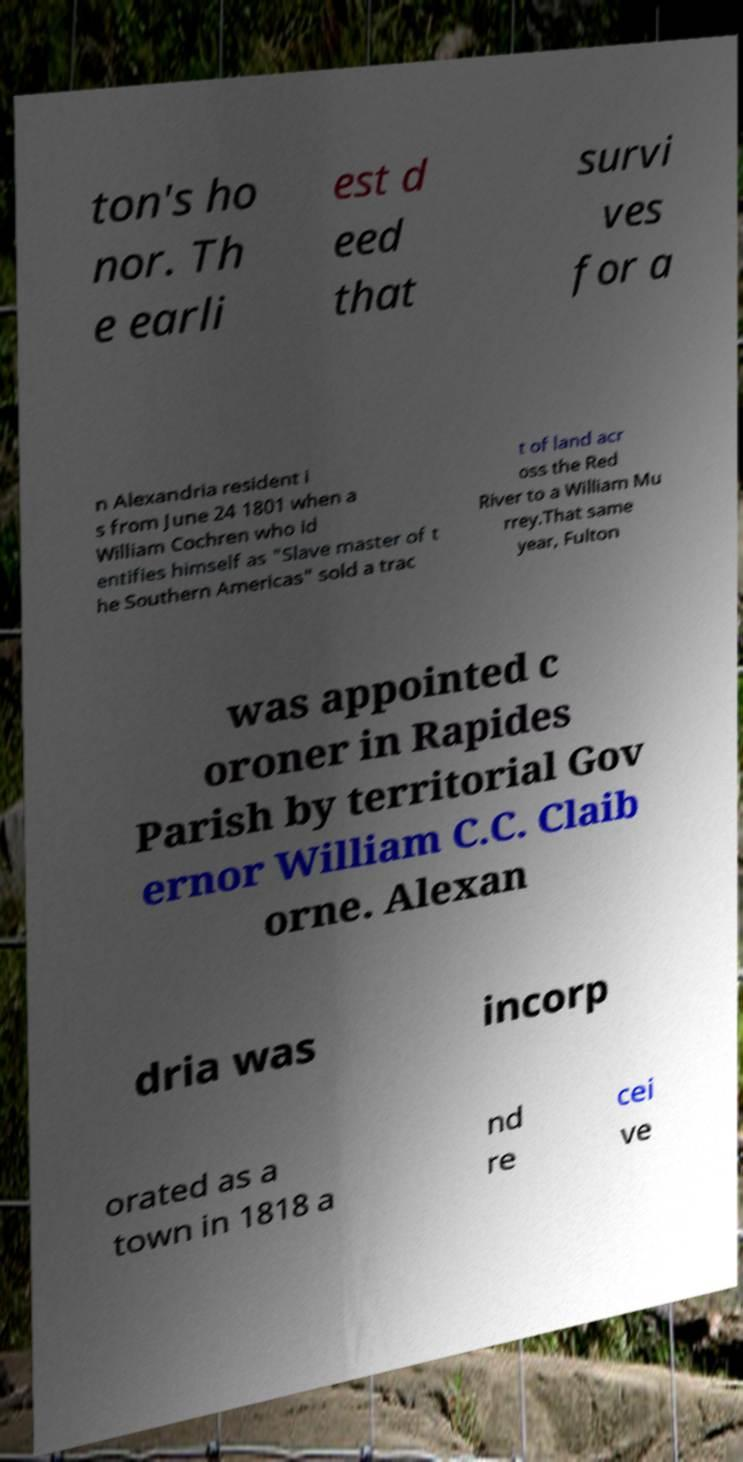Please identify and transcribe the text found in this image. ton's ho nor. Th e earli est d eed that survi ves for a n Alexandria resident i s from June 24 1801 when a William Cochren who id entifies himself as "Slave master of t he Southern Americas" sold a trac t of land acr oss the Red River to a William Mu rrey.That same year, Fulton was appointed c oroner in Rapides Parish by territorial Gov ernor William C.C. Claib orne. Alexan dria was incorp orated as a town in 1818 a nd re cei ve 